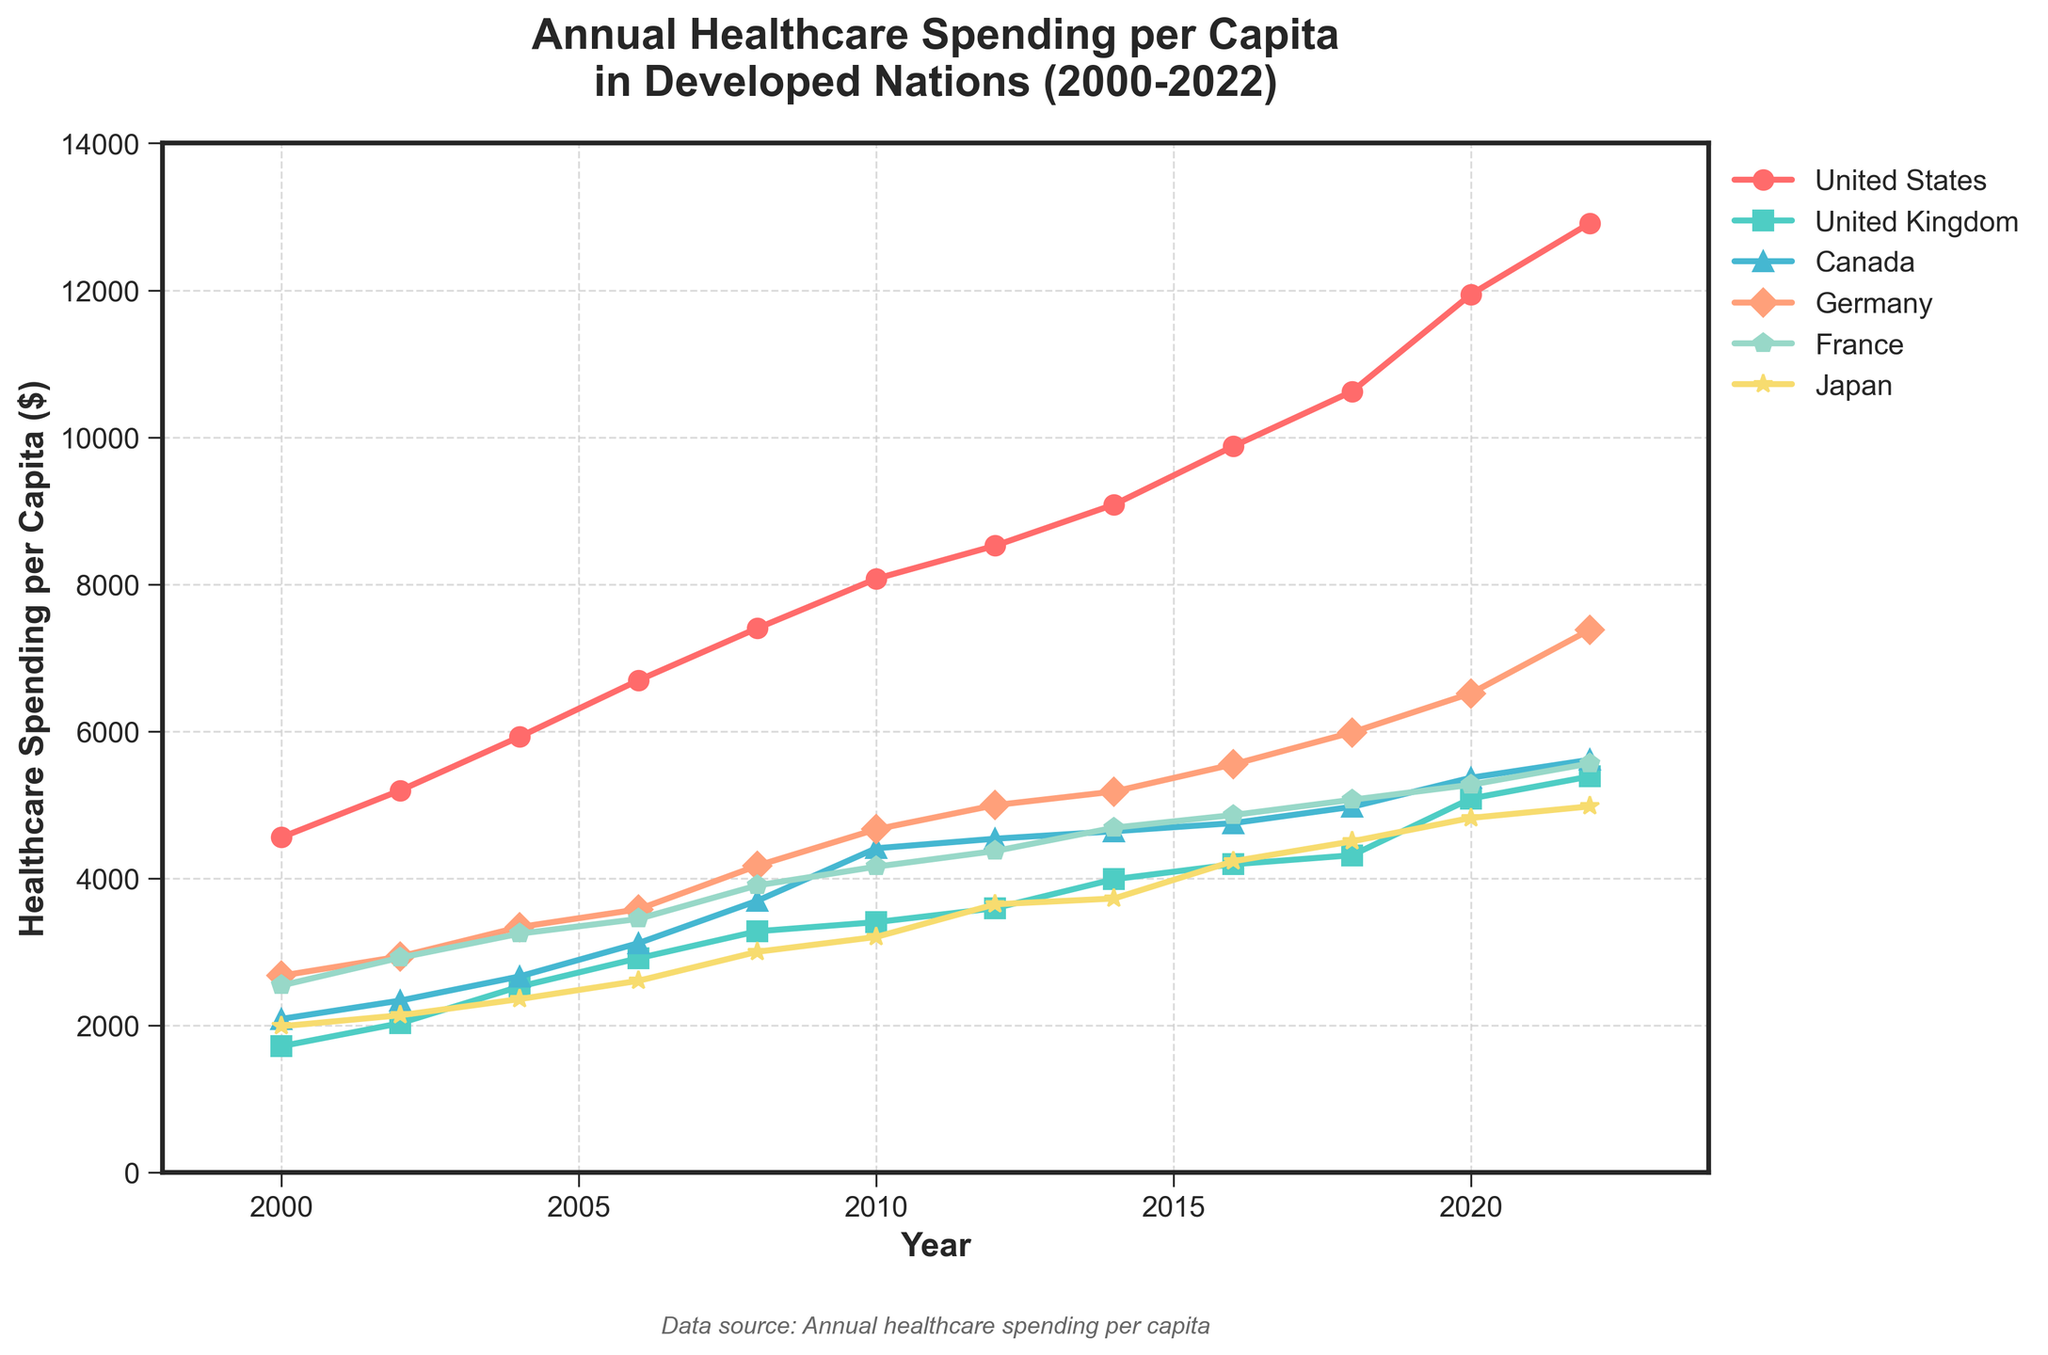Which country had the highest healthcare spending per capita in 2022? The plot shows different countries with the United States spending the highest in 2022 as represented by the topmost line.
Answer: United States What was the difference in healthcare spending per capita between the United States and Japan in 2020? From the figure, in 2020, the United States spending was $11,945, and Japan's spending was $4,823. The difference is $11,945 - $4,823.
Answer: $7,122 Between 2000 and 2022, which country had the most significant increase in healthcare spending per capita? By examining the trends, the United States shows the steepest continuous increase from about $4,559 in 2000 to $12,914 in 2022.
Answer: United States How does the healthcare spending per capita in Germany in 2010 compare to that in the United Kingdom in 2022? In 2010, Germany's spending was $4,668, and in 2022, the United Kingdom's spending was $5,387. Thus, the United Kingdom's 2022 spending is higher.
Answer: The United Kingdom in 2022 What is the combined healthcare spending per capita for France and Canada in 2018? From the figure, France's spending in 2018 was $5,070, and Canada's was $4,974. The combined spending is $5,070 + $4,974.
Answer: $10,044 Which country's healthcare spending per capita increased the least between 2000 and 2022? By observing the rate of increase, Japan shows the least increase from $1,989 in 2000 to $4,980 in 2022 compared to other countries.
Answer: Japan In what year did Canada's healthcare spending per capita first exceed $5,000? By tracing the marker for Canada, spending surpasses $5,000 in 2020.
Answer: 2020 What is the average healthcare spending per capita in France over the years from 2000 to 2022? Sum all France's spending data points from 2000 to 2022 and divide by the number of data points (12 years).
Answer: (2544 + 2922 + 3248 + 3449 + 3905 + 4160 + 4373 + 4690 + 4862 + 5070 + 5274 + 5564) / 12 = $4,290 Which countries' healthcare spending per capita crossed $7,000 by 2022? By 2022, the United States and Germany have spending over $7,000, evident from their respective lines and markers.
Answer: United States and Germany 